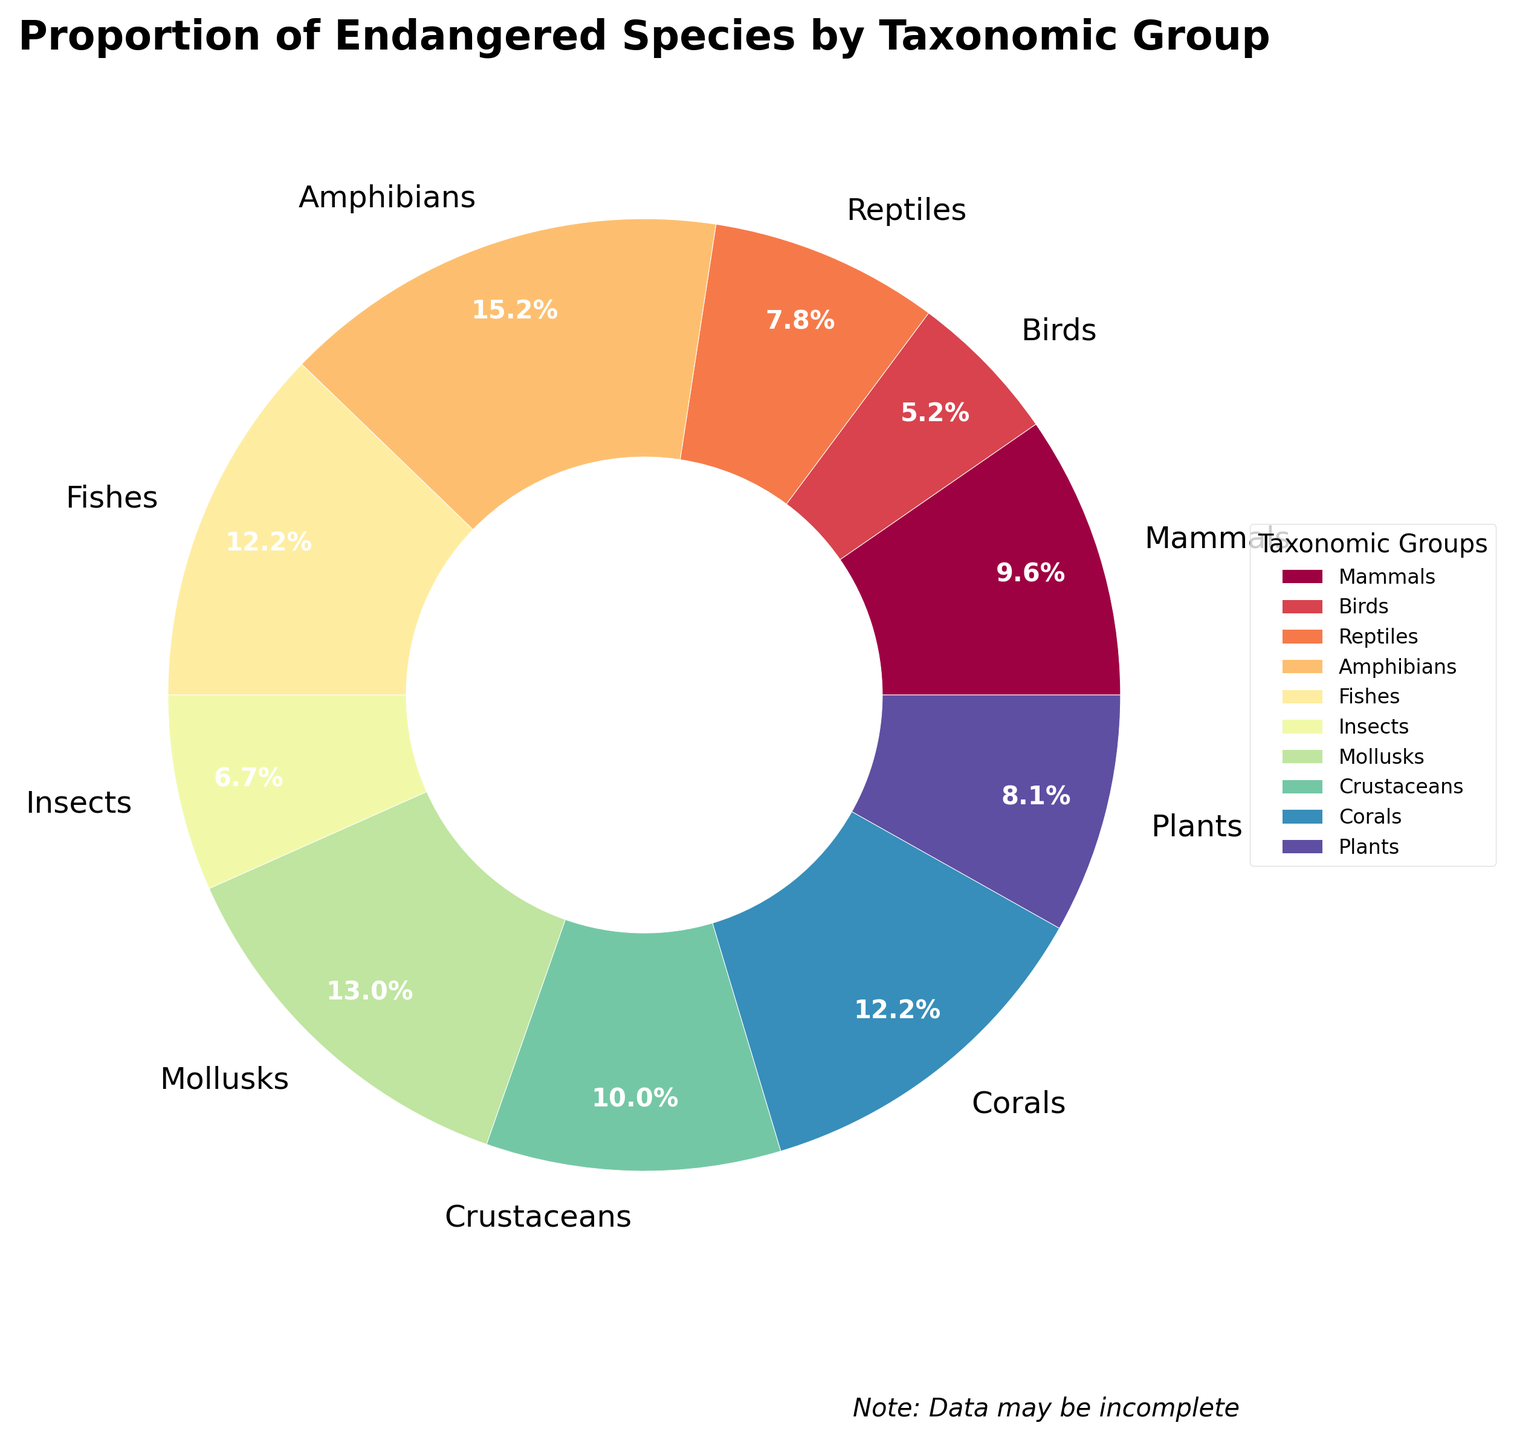Which taxonomic group has the highest proportion of endangered species? The group with the highest percentage in the figure is Amphibians, as they have the largest slice in the pie chart.
Answer: Amphibians Which group has a higher proportion of endangered species, Reptiles or Plants? By comparing the sizes of the slices, we see that Reptiles have 21% and Plants have 22%. Thus, Plants have a slightly higher proportion of endangered species than Reptiles.
Answer: Plants What is the difference in the proportion of endangered species between Mollusks and Birds? Mollusks have 35% while Birds have 14%. Subtracting these values gives 35% - 14% = 21%.
Answer: 21% Are Fishes and Corals equally endangered? By comparing the slices, we observe that both Fishes and Corals have the same proportion of 33%.
Answer: Yes What is the sum of the proportions of endangered species for Mammals, Birds, and Insects? The proportions are Mammals (26%), Birds (14%), and Insects (18%). Summing these values gives 26% + 14% + 18% = 58%.
Answer: 58% Which taxonomic group has the second lowest proportion of endangered species? The group with the second smallest slice after Birds (14%) is Insects (18%).
Answer: Insects What color represents Crustaceans in the pie chart? By observing the color assigned to the slice for Crustaceans, we can identify the specific color used in the visual. Assuming the color assignment follows the default color scheme, Crustaceans are likely represented by one of the darker shades. [Color identification may vary]
Answer: [Observed Color – dependent on the actual plot] If we combine the proportions of endangered species for Mammals and Reptiles, does it exceed the proportion of Amphibians? Mammals have 26% and Reptiles have 21%. Summing these values gives 26% + 21% = 47%, which is greater than Amphibians' 41%.
Answer: Yes 